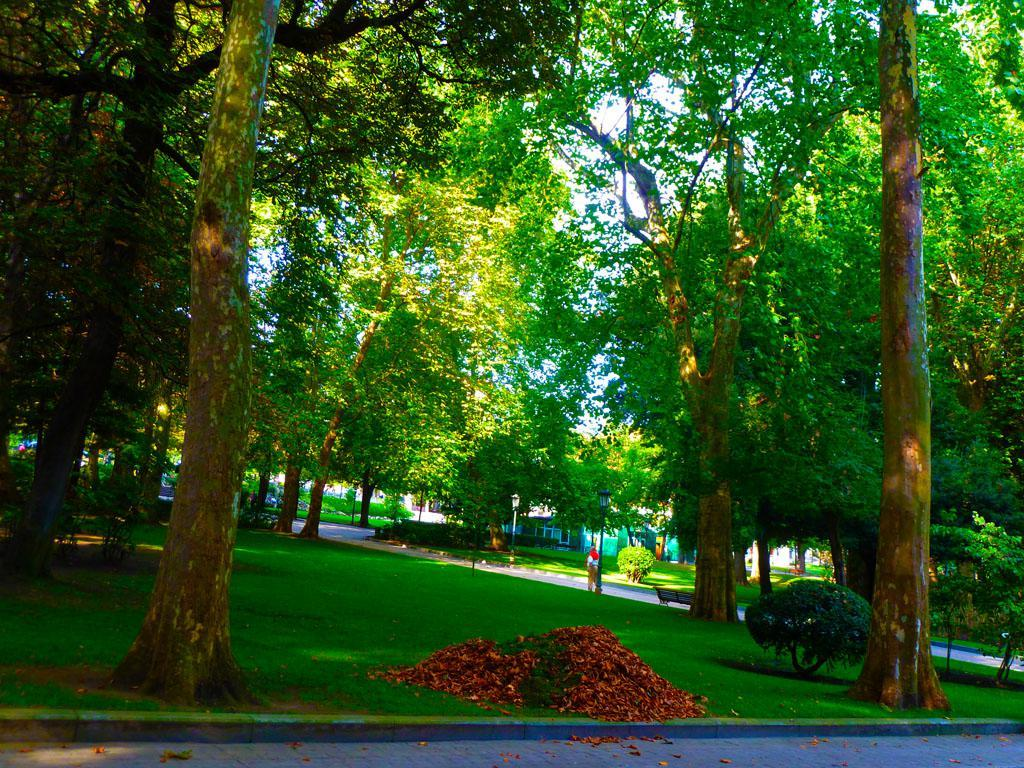What type of vegetation can be seen in the image? There are trees in the image. What type of seating is present in the image? There is a bench in the image. What type of surface can be seen in the image? There are roads in the image. What type of ground cover is present in the image? There is grass in the image. What is visible in the background of the image? The sky is visible in the background of the image. How many legs can be seen on the bike in the image? There is no bike present in the image, so it is not possible to determine the number of legs on a bike. 